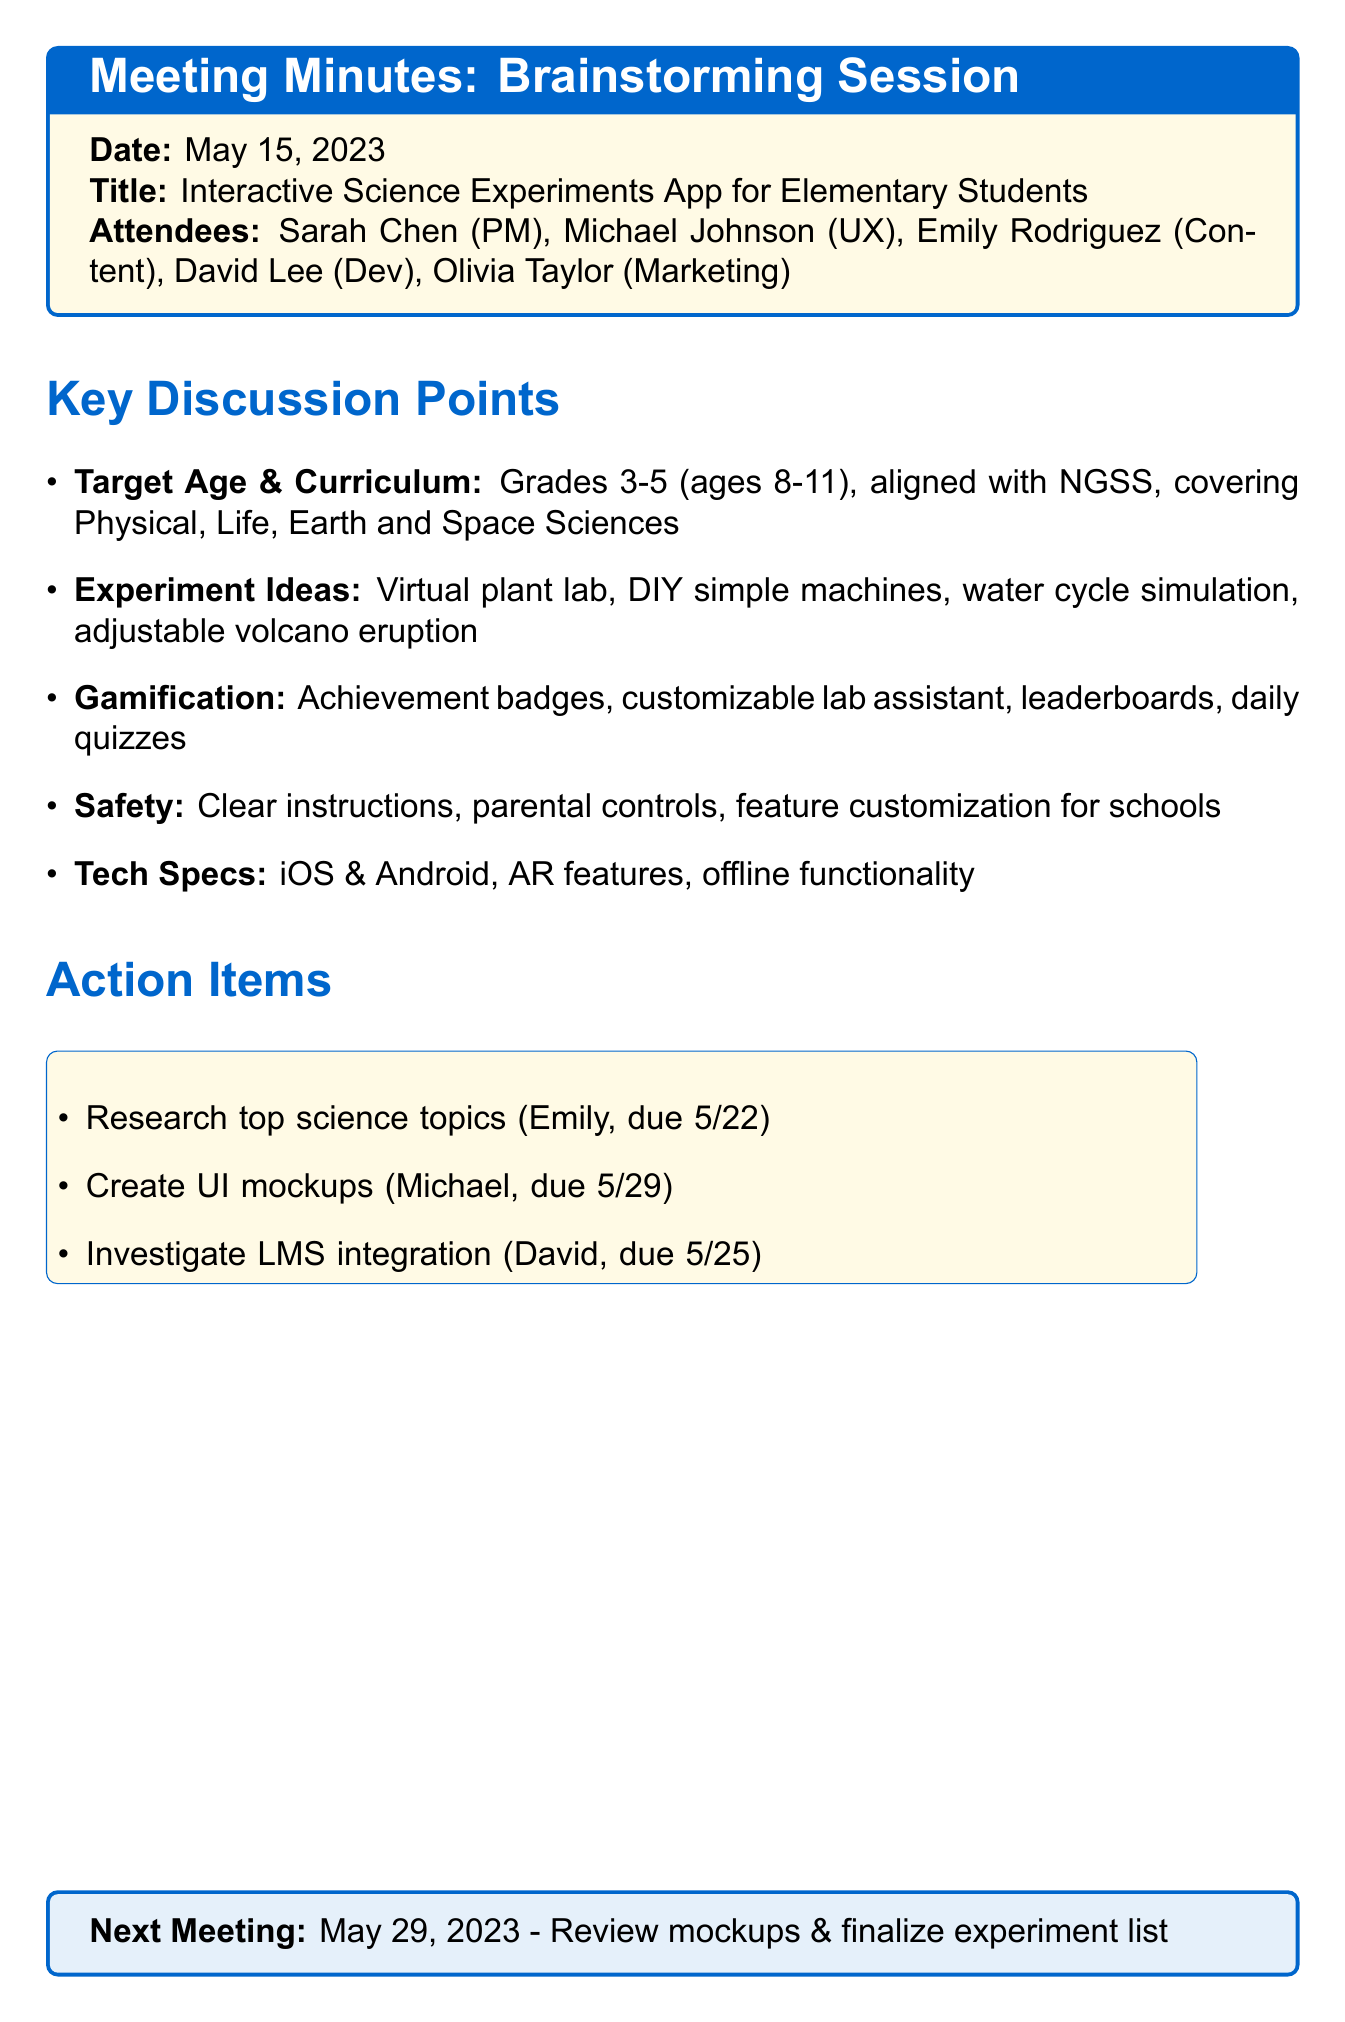What is the meeting date? The meeting date is listed at the beginning of the document.
Answer: May 15, 2023 Who is the Educational Content Specialist? This information can be found in the list of attendees.
Answer: Emily Rodriguez What are the target grades for the app? The discussion points mention the target grades explicitly.
Answer: Grades 3-5 What is one idea for an interactive experiment? The document lists several ideas under discussion points.
Answer: Virtual plant growth lab What is the due date for researching top science topics? This information is stated in the action items section.
Answer: May 22, 2023 What platform will the app be developed for? The technical considerations address the platforms for development.
Answer: iOS and Android What is the focus of the next meeting? The next meeting's focus is outlined at the end of the document.
Answer: Review initial mockups and finalize experiment list How many attendees are listed? The number of attendees is mentioned in the attendees section.
Answer: Five What gamification element involves competition? The document discusses various gamification elements, one of which pertains to competition.
Answer: Leaderboard 